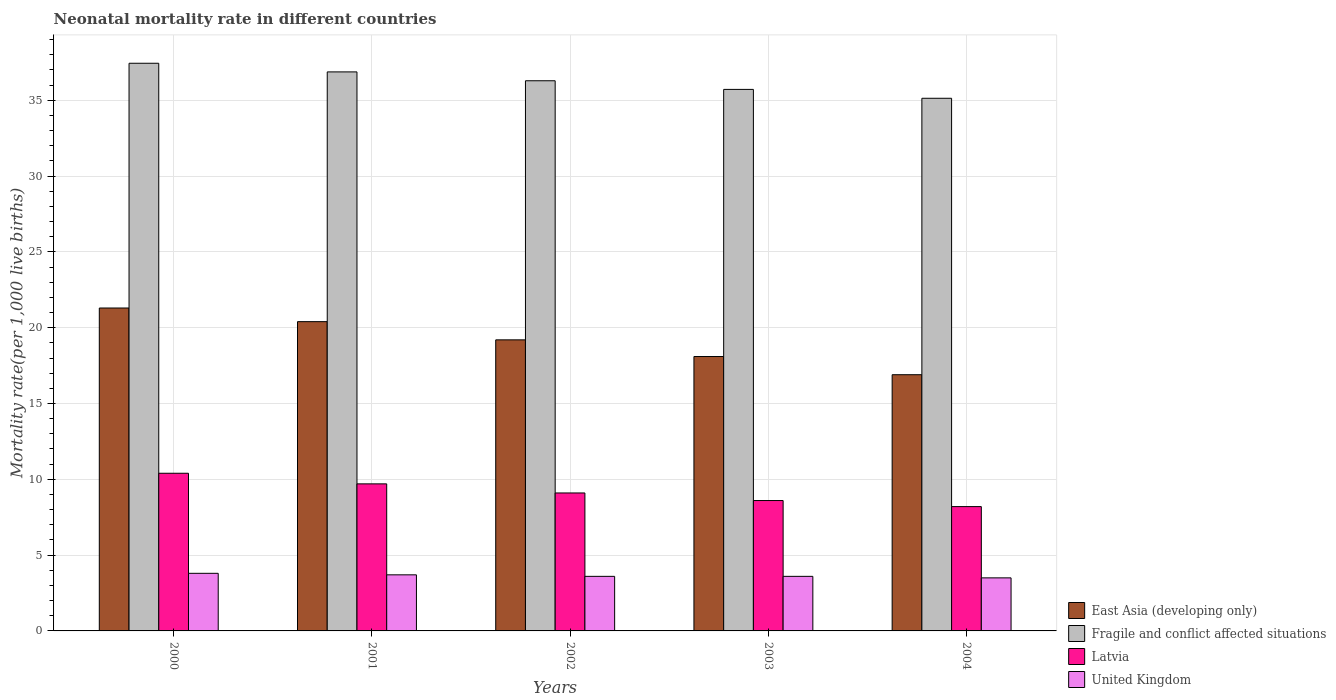How many different coloured bars are there?
Offer a terse response. 4. How many groups of bars are there?
Provide a succinct answer. 5. Are the number of bars per tick equal to the number of legend labels?
Provide a succinct answer. Yes. How many bars are there on the 3rd tick from the right?
Offer a terse response. 4. What is the label of the 3rd group of bars from the left?
Your response must be concise. 2002. In how many cases, is the number of bars for a given year not equal to the number of legend labels?
Provide a short and direct response. 0. What is the neonatal mortality rate in Latvia in 2002?
Make the answer very short. 9.1. Across all years, what is the maximum neonatal mortality rate in East Asia (developing only)?
Your answer should be very brief. 21.3. What is the total neonatal mortality rate in United Kingdom in the graph?
Provide a short and direct response. 18.2. What is the difference between the neonatal mortality rate in Fragile and conflict affected situations in 2003 and that in 2004?
Provide a succinct answer. 0.59. What is the difference between the neonatal mortality rate in East Asia (developing only) in 2000 and the neonatal mortality rate in Fragile and conflict affected situations in 2001?
Provide a short and direct response. -15.57. What is the average neonatal mortality rate in United Kingdom per year?
Offer a very short reply. 3.64. In the year 2003, what is the difference between the neonatal mortality rate in Fragile and conflict affected situations and neonatal mortality rate in East Asia (developing only)?
Keep it short and to the point. 17.62. What is the ratio of the neonatal mortality rate in Latvia in 2000 to that in 2002?
Provide a short and direct response. 1.14. Is the neonatal mortality rate in Latvia in 2000 less than that in 2001?
Your answer should be very brief. No. Is the difference between the neonatal mortality rate in Fragile and conflict affected situations in 2000 and 2004 greater than the difference between the neonatal mortality rate in East Asia (developing only) in 2000 and 2004?
Ensure brevity in your answer.  No. What is the difference between the highest and the second highest neonatal mortality rate in Fragile and conflict affected situations?
Your answer should be very brief. 0.57. What is the difference between the highest and the lowest neonatal mortality rate in Latvia?
Offer a terse response. 2.2. In how many years, is the neonatal mortality rate in United Kingdom greater than the average neonatal mortality rate in United Kingdom taken over all years?
Your answer should be compact. 2. Is the sum of the neonatal mortality rate in United Kingdom in 2000 and 2004 greater than the maximum neonatal mortality rate in East Asia (developing only) across all years?
Make the answer very short. No. What does the 2nd bar from the left in 2000 represents?
Offer a very short reply. Fragile and conflict affected situations. What does the 2nd bar from the right in 2001 represents?
Offer a very short reply. Latvia. How many bars are there?
Your answer should be compact. 20. How many years are there in the graph?
Your answer should be very brief. 5. What is the difference between two consecutive major ticks on the Y-axis?
Provide a short and direct response. 5. Are the values on the major ticks of Y-axis written in scientific E-notation?
Offer a terse response. No. Does the graph contain any zero values?
Make the answer very short. No. Where does the legend appear in the graph?
Your answer should be very brief. Bottom right. What is the title of the graph?
Offer a very short reply. Neonatal mortality rate in different countries. What is the label or title of the X-axis?
Provide a succinct answer. Years. What is the label or title of the Y-axis?
Keep it short and to the point. Mortality rate(per 1,0 live births). What is the Mortality rate(per 1,000 live births) in East Asia (developing only) in 2000?
Your answer should be very brief. 21.3. What is the Mortality rate(per 1,000 live births) in Fragile and conflict affected situations in 2000?
Provide a succinct answer. 37.44. What is the Mortality rate(per 1,000 live births) of Latvia in 2000?
Make the answer very short. 10.4. What is the Mortality rate(per 1,000 live births) in United Kingdom in 2000?
Your response must be concise. 3.8. What is the Mortality rate(per 1,000 live births) of East Asia (developing only) in 2001?
Provide a succinct answer. 20.4. What is the Mortality rate(per 1,000 live births) in Fragile and conflict affected situations in 2001?
Provide a succinct answer. 36.87. What is the Mortality rate(per 1,000 live births) in Latvia in 2001?
Keep it short and to the point. 9.7. What is the Mortality rate(per 1,000 live births) of United Kingdom in 2001?
Your answer should be compact. 3.7. What is the Mortality rate(per 1,000 live births) of East Asia (developing only) in 2002?
Make the answer very short. 19.2. What is the Mortality rate(per 1,000 live births) in Fragile and conflict affected situations in 2002?
Provide a short and direct response. 36.29. What is the Mortality rate(per 1,000 live births) of Latvia in 2002?
Make the answer very short. 9.1. What is the Mortality rate(per 1,000 live births) of East Asia (developing only) in 2003?
Provide a short and direct response. 18.1. What is the Mortality rate(per 1,000 live births) of Fragile and conflict affected situations in 2003?
Ensure brevity in your answer.  35.72. What is the Mortality rate(per 1,000 live births) of Latvia in 2003?
Your answer should be very brief. 8.6. What is the Mortality rate(per 1,000 live births) in United Kingdom in 2003?
Your answer should be compact. 3.6. What is the Mortality rate(per 1,000 live births) of Fragile and conflict affected situations in 2004?
Offer a very short reply. 35.13. What is the Mortality rate(per 1,000 live births) in Latvia in 2004?
Offer a very short reply. 8.2. Across all years, what is the maximum Mortality rate(per 1,000 live births) of East Asia (developing only)?
Offer a terse response. 21.3. Across all years, what is the maximum Mortality rate(per 1,000 live births) in Fragile and conflict affected situations?
Keep it short and to the point. 37.44. Across all years, what is the maximum Mortality rate(per 1,000 live births) in Latvia?
Give a very brief answer. 10.4. Across all years, what is the maximum Mortality rate(per 1,000 live births) in United Kingdom?
Offer a very short reply. 3.8. Across all years, what is the minimum Mortality rate(per 1,000 live births) of East Asia (developing only)?
Provide a succinct answer. 16.9. Across all years, what is the minimum Mortality rate(per 1,000 live births) in Fragile and conflict affected situations?
Ensure brevity in your answer.  35.13. What is the total Mortality rate(per 1,000 live births) of East Asia (developing only) in the graph?
Ensure brevity in your answer.  95.9. What is the total Mortality rate(per 1,000 live births) in Fragile and conflict affected situations in the graph?
Offer a terse response. 181.46. What is the total Mortality rate(per 1,000 live births) of Latvia in the graph?
Provide a succinct answer. 46. What is the total Mortality rate(per 1,000 live births) of United Kingdom in the graph?
Ensure brevity in your answer.  18.2. What is the difference between the Mortality rate(per 1,000 live births) of Fragile and conflict affected situations in 2000 and that in 2001?
Your response must be concise. 0.57. What is the difference between the Mortality rate(per 1,000 live births) of United Kingdom in 2000 and that in 2001?
Keep it short and to the point. 0.1. What is the difference between the Mortality rate(per 1,000 live births) of East Asia (developing only) in 2000 and that in 2002?
Your response must be concise. 2.1. What is the difference between the Mortality rate(per 1,000 live births) in Fragile and conflict affected situations in 2000 and that in 2002?
Give a very brief answer. 1.15. What is the difference between the Mortality rate(per 1,000 live births) of East Asia (developing only) in 2000 and that in 2003?
Provide a succinct answer. 3.2. What is the difference between the Mortality rate(per 1,000 live births) in Fragile and conflict affected situations in 2000 and that in 2003?
Keep it short and to the point. 1.72. What is the difference between the Mortality rate(per 1,000 live births) of East Asia (developing only) in 2000 and that in 2004?
Ensure brevity in your answer.  4.4. What is the difference between the Mortality rate(per 1,000 live births) of Fragile and conflict affected situations in 2000 and that in 2004?
Provide a short and direct response. 2.31. What is the difference between the Mortality rate(per 1,000 live births) in Fragile and conflict affected situations in 2001 and that in 2002?
Your answer should be compact. 0.58. What is the difference between the Mortality rate(per 1,000 live births) of East Asia (developing only) in 2001 and that in 2003?
Give a very brief answer. 2.3. What is the difference between the Mortality rate(per 1,000 live births) of Fragile and conflict affected situations in 2001 and that in 2003?
Make the answer very short. 1.15. What is the difference between the Mortality rate(per 1,000 live births) of Latvia in 2001 and that in 2003?
Offer a very short reply. 1.1. What is the difference between the Mortality rate(per 1,000 live births) in United Kingdom in 2001 and that in 2003?
Give a very brief answer. 0.1. What is the difference between the Mortality rate(per 1,000 live births) of East Asia (developing only) in 2001 and that in 2004?
Make the answer very short. 3.5. What is the difference between the Mortality rate(per 1,000 live births) of Fragile and conflict affected situations in 2001 and that in 2004?
Provide a short and direct response. 1.74. What is the difference between the Mortality rate(per 1,000 live births) of Latvia in 2001 and that in 2004?
Your answer should be compact. 1.5. What is the difference between the Mortality rate(per 1,000 live births) in United Kingdom in 2001 and that in 2004?
Provide a succinct answer. 0.2. What is the difference between the Mortality rate(per 1,000 live births) of Fragile and conflict affected situations in 2002 and that in 2003?
Provide a short and direct response. 0.57. What is the difference between the Mortality rate(per 1,000 live births) of United Kingdom in 2002 and that in 2003?
Your answer should be compact. 0. What is the difference between the Mortality rate(per 1,000 live births) in Fragile and conflict affected situations in 2002 and that in 2004?
Your answer should be compact. 1.16. What is the difference between the Mortality rate(per 1,000 live births) in East Asia (developing only) in 2003 and that in 2004?
Your response must be concise. 1.2. What is the difference between the Mortality rate(per 1,000 live births) of Fragile and conflict affected situations in 2003 and that in 2004?
Ensure brevity in your answer.  0.59. What is the difference between the Mortality rate(per 1,000 live births) of United Kingdom in 2003 and that in 2004?
Your response must be concise. 0.1. What is the difference between the Mortality rate(per 1,000 live births) in East Asia (developing only) in 2000 and the Mortality rate(per 1,000 live births) in Fragile and conflict affected situations in 2001?
Provide a succinct answer. -15.57. What is the difference between the Mortality rate(per 1,000 live births) of East Asia (developing only) in 2000 and the Mortality rate(per 1,000 live births) of Latvia in 2001?
Provide a succinct answer. 11.6. What is the difference between the Mortality rate(per 1,000 live births) of Fragile and conflict affected situations in 2000 and the Mortality rate(per 1,000 live births) of Latvia in 2001?
Provide a succinct answer. 27.74. What is the difference between the Mortality rate(per 1,000 live births) in Fragile and conflict affected situations in 2000 and the Mortality rate(per 1,000 live births) in United Kingdom in 2001?
Provide a short and direct response. 33.74. What is the difference between the Mortality rate(per 1,000 live births) of Latvia in 2000 and the Mortality rate(per 1,000 live births) of United Kingdom in 2001?
Give a very brief answer. 6.7. What is the difference between the Mortality rate(per 1,000 live births) of East Asia (developing only) in 2000 and the Mortality rate(per 1,000 live births) of Fragile and conflict affected situations in 2002?
Offer a very short reply. -14.99. What is the difference between the Mortality rate(per 1,000 live births) of Fragile and conflict affected situations in 2000 and the Mortality rate(per 1,000 live births) of Latvia in 2002?
Ensure brevity in your answer.  28.34. What is the difference between the Mortality rate(per 1,000 live births) of Fragile and conflict affected situations in 2000 and the Mortality rate(per 1,000 live births) of United Kingdom in 2002?
Offer a terse response. 33.84. What is the difference between the Mortality rate(per 1,000 live births) in East Asia (developing only) in 2000 and the Mortality rate(per 1,000 live births) in Fragile and conflict affected situations in 2003?
Give a very brief answer. -14.42. What is the difference between the Mortality rate(per 1,000 live births) of East Asia (developing only) in 2000 and the Mortality rate(per 1,000 live births) of Latvia in 2003?
Make the answer very short. 12.7. What is the difference between the Mortality rate(per 1,000 live births) of East Asia (developing only) in 2000 and the Mortality rate(per 1,000 live births) of United Kingdom in 2003?
Give a very brief answer. 17.7. What is the difference between the Mortality rate(per 1,000 live births) in Fragile and conflict affected situations in 2000 and the Mortality rate(per 1,000 live births) in Latvia in 2003?
Your response must be concise. 28.84. What is the difference between the Mortality rate(per 1,000 live births) in Fragile and conflict affected situations in 2000 and the Mortality rate(per 1,000 live births) in United Kingdom in 2003?
Give a very brief answer. 33.84. What is the difference between the Mortality rate(per 1,000 live births) of Latvia in 2000 and the Mortality rate(per 1,000 live births) of United Kingdom in 2003?
Offer a terse response. 6.8. What is the difference between the Mortality rate(per 1,000 live births) in East Asia (developing only) in 2000 and the Mortality rate(per 1,000 live births) in Fragile and conflict affected situations in 2004?
Your response must be concise. -13.83. What is the difference between the Mortality rate(per 1,000 live births) in East Asia (developing only) in 2000 and the Mortality rate(per 1,000 live births) in Latvia in 2004?
Give a very brief answer. 13.1. What is the difference between the Mortality rate(per 1,000 live births) of East Asia (developing only) in 2000 and the Mortality rate(per 1,000 live births) of United Kingdom in 2004?
Offer a terse response. 17.8. What is the difference between the Mortality rate(per 1,000 live births) in Fragile and conflict affected situations in 2000 and the Mortality rate(per 1,000 live births) in Latvia in 2004?
Provide a succinct answer. 29.24. What is the difference between the Mortality rate(per 1,000 live births) of Fragile and conflict affected situations in 2000 and the Mortality rate(per 1,000 live births) of United Kingdom in 2004?
Your answer should be compact. 33.94. What is the difference between the Mortality rate(per 1,000 live births) in Latvia in 2000 and the Mortality rate(per 1,000 live births) in United Kingdom in 2004?
Offer a very short reply. 6.9. What is the difference between the Mortality rate(per 1,000 live births) in East Asia (developing only) in 2001 and the Mortality rate(per 1,000 live births) in Fragile and conflict affected situations in 2002?
Make the answer very short. -15.89. What is the difference between the Mortality rate(per 1,000 live births) of Fragile and conflict affected situations in 2001 and the Mortality rate(per 1,000 live births) of Latvia in 2002?
Provide a short and direct response. 27.77. What is the difference between the Mortality rate(per 1,000 live births) of Fragile and conflict affected situations in 2001 and the Mortality rate(per 1,000 live births) of United Kingdom in 2002?
Your answer should be very brief. 33.27. What is the difference between the Mortality rate(per 1,000 live births) of East Asia (developing only) in 2001 and the Mortality rate(per 1,000 live births) of Fragile and conflict affected situations in 2003?
Your answer should be compact. -15.32. What is the difference between the Mortality rate(per 1,000 live births) in East Asia (developing only) in 2001 and the Mortality rate(per 1,000 live births) in Latvia in 2003?
Ensure brevity in your answer.  11.8. What is the difference between the Mortality rate(per 1,000 live births) in Fragile and conflict affected situations in 2001 and the Mortality rate(per 1,000 live births) in Latvia in 2003?
Your answer should be very brief. 28.27. What is the difference between the Mortality rate(per 1,000 live births) of Fragile and conflict affected situations in 2001 and the Mortality rate(per 1,000 live births) of United Kingdom in 2003?
Offer a terse response. 33.27. What is the difference between the Mortality rate(per 1,000 live births) of Latvia in 2001 and the Mortality rate(per 1,000 live births) of United Kingdom in 2003?
Provide a short and direct response. 6.1. What is the difference between the Mortality rate(per 1,000 live births) in East Asia (developing only) in 2001 and the Mortality rate(per 1,000 live births) in Fragile and conflict affected situations in 2004?
Offer a very short reply. -14.73. What is the difference between the Mortality rate(per 1,000 live births) in Fragile and conflict affected situations in 2001 and the Mortality rate(per 1,000 live births) in Latvia in 2004?
Make the answer very short. 28.67. What is the difference between the Mortality rate(per 1,000 live births) in Fragile and conflict affected situations in 2001 and the Mortality rate(per 1,000 live births) in United Kingdom in 2004?
Your response must be concise. 33.37. What is the difference between the Mortality rate(per 1,000 live births) in Latvia in 2001 and the Mortality rate(per 1,000 live births) in United Kingdom in 2004?
Keep it short and to the point. 6.2. What is the difference between the Mortality rate(per 1,000 live births) of East Asia (developing only) in 2002 and the Mortality rate(per 1,000 live births) of Fragile and conflict affected situations in 2003?
Ensure brevity in your answer.  -16.52. What is the difference between the Mortality rate(per 1,000 live births) of East Asia (developing only) in 2002 and the Mortality rate(per 1,000 live births) of United Kingdom in 2003?
Provide a succinct answer. 15.6. What is the difference between the Mortality rate(per 1,000 live births) in Fragile and conflict affected situations in 2002 and the Mortality rate(per 1,000 live births) in Latvia in 2003?
Keep it short and to the point. 27.69. What is the difference between the Mortality rate(per 1,000 live births) in Fragile and conflict affected situations in 2002 and the Mortality rate(per 1,000 live births) in United Kingdom in 2003?
Keep it short and to the point. 32.69. What is the difference between the Mortality rate(per 1,000 live births) of East Asia (developing only) in 2002 and the Mortality rate(per 1,000 live births) of Fragile and conflict affected situations in 2004?
Give a very brief answer. -15.93. What is the difference between the Mortality rate(per 1,000 live births) in East Asia (developing only) in 2002 and the Mortality rate(per 1,000 live births) in United Kingdom in 2004?
Your response must be concise. 15.7. What is the difference between the Mortality rate(per 1,000 live births) in Fragile and conflict affected situations in 2002 and the Mortality rate(per 1,000 live births) in Latvia in 2004?
Give a very brief answer. 28.09. What is the difference between the Mortality rate(per 1,000 live births) in Fragile and conflict affected situations in 2002 and the Mortality rate(per 1,000 live births) in United Kingdom in 2004?
Give a very brief answer. 32.79. What is the difference between the Mortality rate(per 1,000 live births) in Latvia in 2002 and the Mortality rate(per 1,000 live births) in United Kingdom in 2004?
Give a very brief answer. 5.6. What is the difference between the Mortality rate(per 1,000 live births) in East Asia (developing only) in 2003 and the Mortality rate(per 1,000 live births) in Fragile and conflict affected situations in 2004?
Your answer should be very brief. -17.03. What is the difference between the Mortality rate(per 1,000 live births) of East Asia (developing only) in 2003 and the Mortality rate(per 1,000 live births) of Latvia in 2004?
Provide a succinct answer. 9.9. What is the difference between the Mortality rate(per 1,000 live births) in Fragile and conflict affected situations in 2003 and the Mortality rate(per 1,000 live births) in Latvia in 2004?
Make the answer very short. 27.52. What is the difference between the Mortality rate(per 1,000 live births) of Fragile and conflict affected situations in 2003 and the Mortality rate(per 1,000 live births) of United Kingdom in 2004?
Keep it short and to the point. 32.22. What is the average Mortality rate(per 1,000 live births) in East Asia (developing only) per year?
Make the answer very short. 19.18. What is the average Mortality rate(per 1,000 live births) of Fragile and conflict affected situations per year?
Ensure brevity in your answer.  36.29. What is the average Mortality rate(per 1,000 live births) in United Kingdom per year?
Your answer should be compact. 3.64. In the year 2000, what is the difference between the Mortality rate(per 1,000 live births) of East Asia (developing only) and Mortality rate(per 1,000 live births) of Fragile and conflict affected situations?
Provide a succinct answer. -16.14. In the year 2000, what is the difference between the Mortality rate(per 1,000 live births) in Fragile and conflict affected situations and Mortality rate(per 1,000 live births) in Latvia?
Give a very brief answer. 27.04. In the year 2000, what is the difference between the Mortality rate(per 1,000 live births) in Fragile and conflict affected situations and Mortality rate(per 1,000 live births) in United Kingdom?
Provide a succinct answer. 33.64. In the year 2001, what is the difference between the Mortality rate(per 1,000 live births) of East Asia (developing only) and Mortality rate(per 1,000 live births) of Fragile and conflict affected situations?
Offer a very short reply. -16.47. In the year 2001, what is the difference between the Mortality rate(per 1,000 live births) of East Asia (developing only) and Mortality rate(per 1,000 live births) of Latvia?
Keep it short and to the point. 10.7. In the year 2001, what is the difference between the Mortality rate(per 1,000 live births) of Fragile and conflict affected situations and Mortality rate(per 1,000 live births) of Latvia?
Your response must be concise. 27.17. In the year 2001, what is the difference between the Mortality rate(per 1,000 live births) of Fragile and conflict affected situations and Mortality rate(per 1,000 live births) of United Kingdom?
Give a very brief answer. 33.17. In the year 2001, what is the difference between the Mortality rate(per 1,000 live births) of Latvia and Mortality rate(per 1,000 live births) of United Kingdom?
Your answer should be very brief. 6. In the year 2002, what is the difference between the Mortality rate(per 1,000 live births) of East Asia (developing only) and Mortality rate(per 1,000 live births) of Fragile and conflict affected situations?
Offer a terse response. -17.09. In the year 2002, what is the difference between the Mortality rate(per 1,000 live births) in Fragile and conflict affected situations and Mortality rate(per 1,000 live births) in Latvia?
Keep it short and to the point. 27.19. In the year 2002, what is the difference between the Mortality rate(per 1,000 live births) in Fragile and conflict affected situations and Mortality rate(per 1,000 live births) in United Kingdom?
Give a very brief answer. 32.69. In the year 2003, what is the difference between the Mortality rate(per 1,000 live births) of East Asia (developing only) and Mortality rate(per 1,000 live births) of Fragile and conflict affected situations?
Offer a terse response. -17.62. In the year 2003, what is the difference between the Mortality rate(per 1,000 live births) of East Asia (developing only) and Mortality rate(per 1,000 live births) of United Kingdom?
Provide a succinct answer. 14.5. In the year 2003, what is the difference between the Mortality rate(per 1,000 live births) in Fragile and conflict affected situations and Mortality rate(per 1,000 live births) in Latvia?
Provide a short and direct response. 27.12. In the year 2003, what is the difference between the Mortality rate(per 1,000 live births) of Fragile and conflict affected situations and Mortality rate(per 1,000 live births) of United Kingdom?
Give a very brief answer. 32.12. In the year 2004, what is the difference between the Mortality rate(per 1,000 live births) of East Asia (developing only) and Mortality rate(per 1,000 live births) of Fragile and conflict affected situations?
Offer a very short reply. -18.23. In the year 2004, what is the difference between the Mortality rate(per 1,000 live births) of East Asia (developing only) and Mortality rate(per 1,000 live births) of Latvia?
Offer a very short reply. 8.7. In the year 2004, what is the difference between the Mortality rate(per 1,000 live births) of Fragile and conflict affected situations and Mortality rate(per 1,000 live births) of Latvia?
Your response must be concise. 26.93. In the year 2004, what is the difference between the Mortality rate(per 1,000 live births) of Fragile and conflict affected situations and Mortality rate(per 1,000 live births) of United Kingdom?
Your response must be concise. 31.63. In the year 2004, what is the difference between the Mortality rate(per 1,000 live births) in Latvia and Mortality rate(per 1,000 live births) in United Kingdom?
Give a very brief answer. 4.7. What is the ratio of the Mortality rate(per 1,000 live births) in East Asia (developing only) in 2000 to that in 2001?
Provide a succinct answer. 1.04. What is the ratio of the Mortality rate(per 1,000 live births) in Fragile and conflict affected situations in 2000 to that in 2001?
Your answer should be very brief. 1.02. What is the ratio of the Mortality rate(per 1,000 live births) of Latvia in 2000 to that in 2001?
Your answer should be compact. 1.07. What is the ratio of the Mortality rate(per 1,000 live births) of East Asia (developing only) in 2000 to that in 2002?
Provide a short and direct response. 1.11. What is the ratio of the Mortality rate(per 1,000 live births) of Fragile and conflict affected situations in 2000 to that in 2002?
Your answer should be very brief. 1.03. What is the ratio of the Mortality rate(per 1,000 live births) in Latvia in 2000 to that in 2002?
Keep it short and to the point. 1.14. What is the ratio of the Mortality rate(per 1,000 live births) in United Kingdom in 2000 to that in 2002?
Keep it short and to the point. 1.06. What is the ratio of the Mortality rate(per 1,000 live births) in East Asia (developing only) in 2000 to that in 2003?
Offer a terse response. 1.18. What is the ratio of the Mortality rate(per 1,000 live births) of Fragile and conflict affected situations in 2000 to that in 2003?
Make the answer very short. 1.05. What is the ratio of the Mortality rate(per 1,000 live births) in Latvia in 2000 to that in 2003?
Provide a short and direct response. 1.21. What is the ratio of the Mortality rate(per 1,000 live births) of United Kingdom in 2000 to that in 2003?
Provide a short and direct response. 1.06. What is the ratio of the Mortality rate(per 1,000 live births) of East Asia (developing only) in 2000 to that in 2004?
Your answer should be compact. 1.26. What is the ratio of the Mortality rate(per 1,000 live births) of Fragile and conflict affected situations in 2000 to that in 2004?
Ensure brevity in your answer.  1.07. What is the ratio of the Mortality rate(per 1,000 live births) of Latvia in 2000 to that in 2004?
Ensure brevity in your answer.  1.27. What is the ratio of the Mortality rate(per 1,000 live births) in United Kingdom in 2000 to that in 2004?
Offer a very short reply. 1.09. What is the ratio of the Mortality rate(per 1,000 live births) of Fragile and conflict affected situations in 2001 to that in 2002?
Your response must be concise. 1.02. What is the ratio of the Mortality rate(per 1,000 live births) of Latvia in 2001 to that in 2002?
Offer a terse response. 1.07. What is the ratio of the Mortality rate(per 1,000 live births) of United Kingdom in 2001 to that in 2002?
Your answer should be very brief. 1.03. What is the ratio of the Mortality rate(per 1,000 live births) of East Asia (developing only) in 2001 to that in 2003?
Give a very brief answer. 1.13. What is the ratio of the Mortality rate(per 1,000 live births) in Fragile and conflict affected situations in 2001 to that in 2003?
Ensure brevity in your answer.  1.03. What is the ratio of the Mortality rate(per 1,000 live births) of Latvia in 2001 to that in 2003?
Make the answer very short. 1.13. What is the ratio of the Mortality rate(per 1,000 live births) in United Kingdom in 2001 to that in 2003?
Offer a very short reply. 1.03. What is the ratio of the Mortality rate(per 1,000 live births) in East Asia (developing only) in 2001 to that in 2004?
Offer a terse response. 1.21. What is the ratio of the Mortality rate(per 1,000 live births) in Fragile and conflict affected situations in 2001 to that in 2004?
Your response must be concise. 1.05. What is the ratio of the Mortality rate(per 1,000 live births) of Latvia in 2001 to that in 2004?
Your answer should be very brief. 1.18. What is the ratio of the Mortality rate(per 1,000 live births) of United Kingdom in 2001 to that in 2004?
Offer a very short reply. 1.06. What is the ratio of the Mortality rate(per 1,000 live births) in East Asia (developing only) in 2002 to that in 2003?
Keep it short and to the point. 1.06. What is the ratio of the Mortality rate(per 1,000 live births) of Latvia in 2002 to that in 2003?
Your response must be concise. 1.06. What is the ratio of the Mortality rate(per 1,000 live births) of East Asia (developing only) in 2002 to that in 2004?
Provide a short and direct response. 1.14. What is the ratio of the Mortality rate(per 1,000 live births) of Fragile and conflict affected situations in 2002 to that in 2004?
Your answer should be very brief. 1.03. What is the ratio of the Mortality rate(per 1,000 live births) of Latvia in 2002 to that in 2004?
Offer a terse response. 1.11. What is the ratio of the Mortality rate(per 1,000 live births) of United Kingdom in 2002 to that in 2004?
Your answer should be compact. 1.03. What is the ratio of the Mortality rate(per 1,000 live births) of East Asia (developing only) in 2003 to that in 2004?
Your answer should be very brief. 1.07. What is the ratio of the Mortality rate(per 1,000 live births) in Fragile and conflict affected situations in 2003 to that in 2004?
Make the answer very short. 1.02. What is the ratio of the Mortality rate(per 1,000 live births) in Latvia in 2003 to that in 2004?
Provide a short and direct response. 1.05. What is the ratio of the Mortality rate(per 1,000 live births) of United Kingdom in 2003 to that in 2004?
Your answer should be very brief. 1.03. What is the difference between the highest and the second highest Mortality rate(per 1,000 live births) of East Asia (developing only)?
Your response must be concise. 0.9. What is the difference between the highest and the second highest Mortality rate(per 1,000 live births) in Fragile and conflict affected situations?
Your answer should be very brief. 0.57. What is the difference between the highest and the lowest Mortality rate(per 1,000 live births) of Fragile and conflict affected situations?
Offer a very short reply. 2.31. What is the difference between the highest and the lowest Mortality rate(per 1,000 live births) in Latvia?
Your answer should be compact. 2.2. What is the difference between the highest and the lowest Mortality rate(per 1,000 live births) of United Kingdom?
Provide a succinct answer. 0.3. 